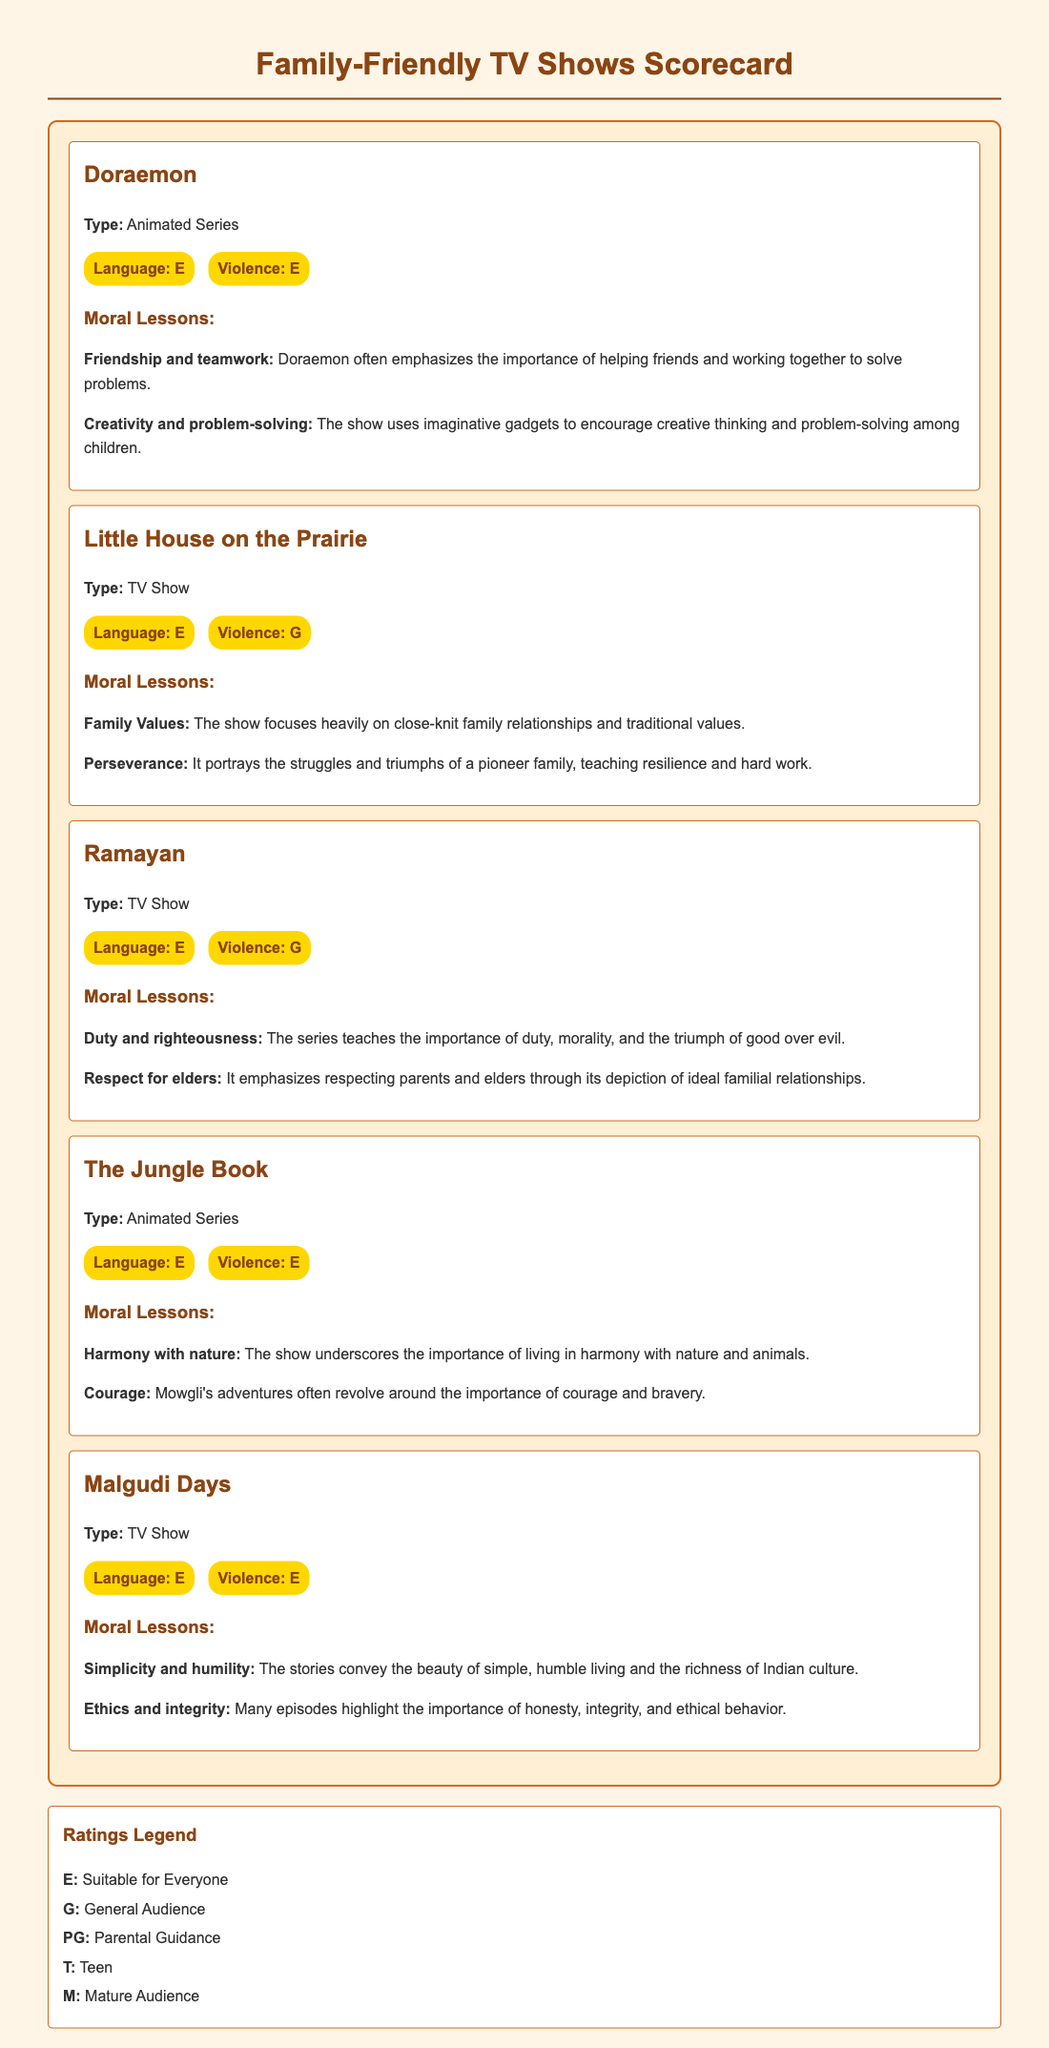What is the first show listed in the scorecard? The scorecard displays a list of family-friendly TV shows, starting with "Doraemon" at the top.
Answer: Doraemon What type of show is "Little House on the Prairie"? The type of show is specified in the document, and "Little House on the Prairie" is categorized as a TV Show.
Answer: TV Show What is the language rating for "Ramayan"? The language rating for "Ramayan" is listed as "E", which indicates suitability for everyone.
Answer: E Which show emphasizes "Courage" as one of its moral lessons? The moral lessons section highlights that "The Jungle Book" teaches the importance of courage through its storyline.
Answer: The Jungle Book How many shows have a violence rating of "E"? Upon review, there are three shows in the scorecard that have a violence rating of "E." These shows are "Doraemon," "The Jungle Book," and "Malgudi Days."
Answer: 3 What moral lesson is shared by both "Ramayan" and "Malgudi Days"? Both of these shows convey values related to family and duty, with "Ramayan" focusing on duty and morality and "Malgudi Days" celebrating the richness of family relationships.
Answer: Family Values What does the "E" rating signify? The document provides a legend defining the ratings, and "E" stands for "Suitable for Everyone."
Answer: Suitable for Everyone How many moral lessons are listed for "Doraemon"? The document specifies two moral lessons for "Doraemon" related to friendship and creativity.
Answer: 2 